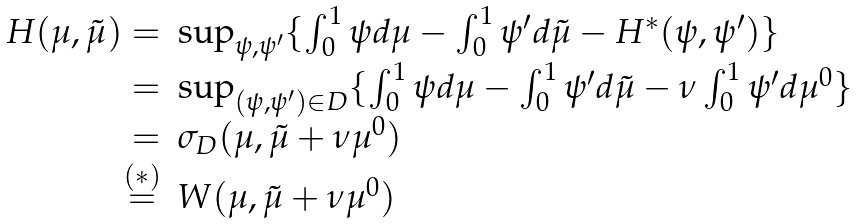Convert formula to latex. <formula><loc_0><loc_0><loc_500><loc_500>\begin{array} { r l } H ( \mu , \tilde { \mu } ) = & \sup _ { \psi , \psi ^ { \prime } } \{ \int _ { 0 } ^ { 1 } \psi d \mu - \int _ { 0 } ^ { 1 } \psi ^ { \prime } d \tilde { \mu } - H ^ { * } ( \psi , \psi ^ { \prime } ) \} \\ = & \sup _ { ( \psi , \psi ^ { \prime } ) \in D } \{ \int _ { 0 } ^ { 1 } \psi d \mu - \int _ { 0 } ^ { 1 } \psi ^ { \prime } d \tilde { \mu } - \nu \int _ { 0 } ^ { 1 } \psi ^ { \prime } d \mu ^ { 0 } \} \\ = & \sigma _ { D } ( \mu , \tilde { \mu } + \nu \mu ^ { 0 } ) \\ \overset { ( * ) } { = } & W ( \mu , \tilde { \mu } + \nu \mu ^ { 0 } ) \end{array}</formula> 